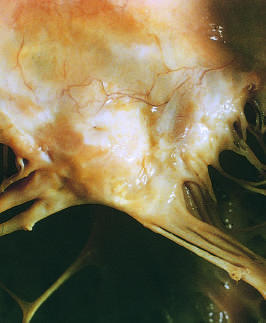what is there marked as seen from above the valve?
Answer the question using a single word or phrase. Left atrial dilation 